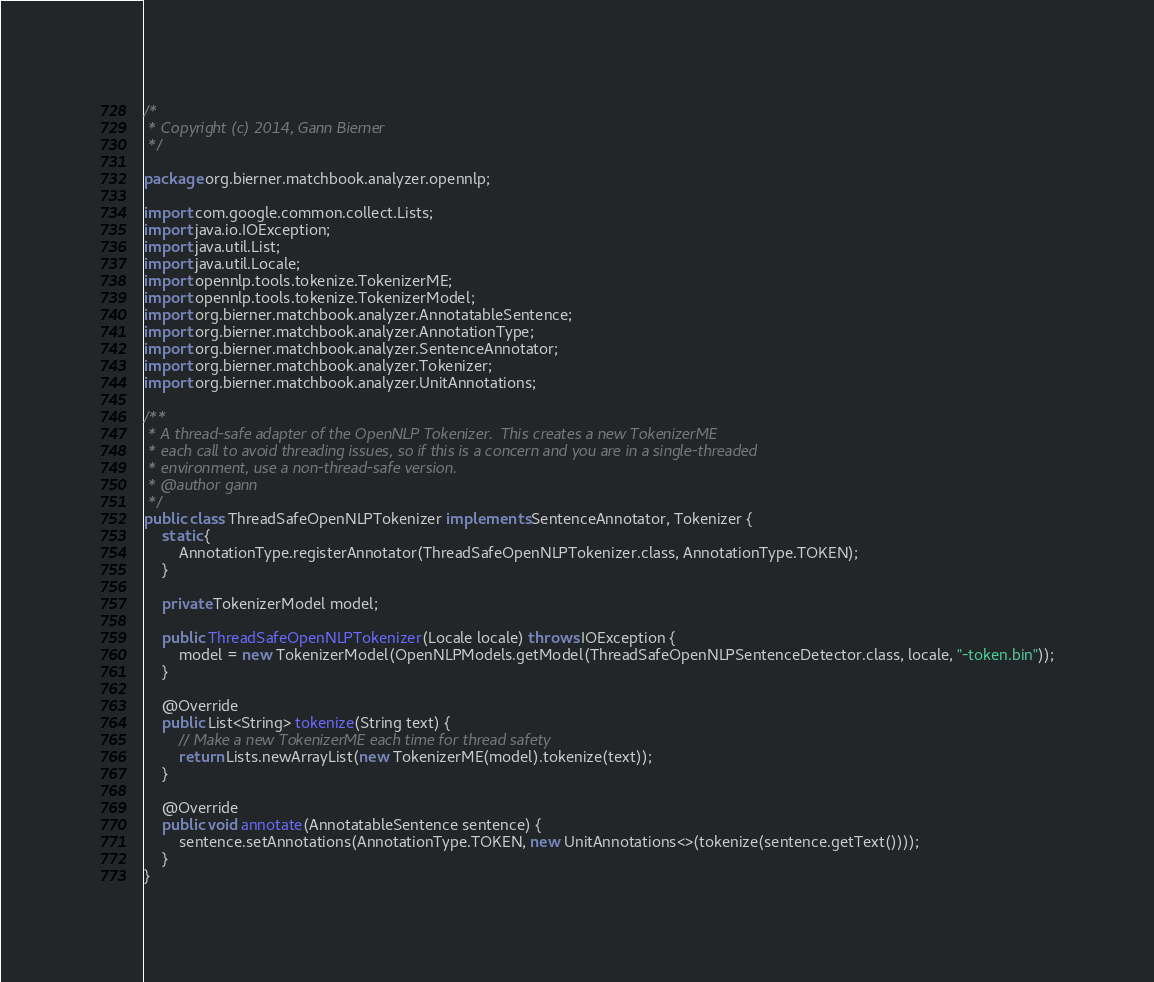Convert code to text. <code><loc_0><loc_0><loc_500><loc_500><_Java_>/*
 * Copyright (c) 2014, Gann Bierner
 */

package org.bierner.matchbook.analyzer.opennlp;

import com.google.common.collect.Lists;
import java.io.IOException;
import java.util.List;
import java.util.Locale;
import opennlp.tools.tokenize.TokenizerME;
import opennlp.tools.tokenize.TokenizerModel;
import org.bierner.matchbook.analyzer.AnnotatableSentence;
import org.bierner.matchbook.analyzer.AnnotationType;
import org.bierner.matchbook.analyzer.SentenceAnnotator;
import org.bierner.matchbook.analyzer.Tokenizer;
import org.bierner.matchbook.analyzer.UnitAnnotations;

/**
 * A thread-safe adapter of the OpenNLP Tokenizer.  This creates a new TokenizerME
 * each call to avoid threading issues, so if this is a concern and you are in a single-threaded
 * environment, use a non-thread-safe version.
 * @author gann
 */
public class ThreadSafeOpenNLPTokenizer implements SentenceAnnotator, Tokenizer {
    static {
        AnnotationType.registerAnnotator(ThreadSafeOpenNLPTokenizer.class, AnnotationType.TOKEN);
    }
    
    private TokenizerModel model;
    
    public ThreadSafeOpenNLPTokenizer(Locale locale) throws IOException {
        model = new TokenizerModel(OpenNLPModels.getModel(ThreadSafeOpenNLPSentenceDetector.class, locale, "-token.bin"));
    }
    
    @Override
    public List<String> tokenize(String text) {
        // Make a new TokenizerME each time for thread safety
        return Lists.newArrayList(new TokenizerME(model).tokenize(text));
    }
    
    @Override
    public void annotate(AnnotatableSentence sentence) {
        sentence.setAnnotations(AnnotationType.TOKEN, new UnitAnnotations<>(tokenize(sentence.getText())));
    }
}
</code> 